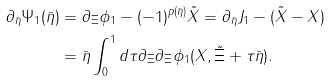<formula> <loc_0><loc_0><loc_500><loc_500>\partial _ { \bar { \eta } } \Psi _ { 1 } ( \bar { \eta } ) & = \partial _ { \Xi } \phi _ { 1 } - ( - 1 ) ^ { p ( \bar { \eta } ) } \tilde { X } = \partial _ { \bar { \eta } } J _ { 1 } - ( \tilde { X } - X ) \\ & = \bar { \eta } \int _ { 0 } ^ { 1 } d \tau \partial _ { \Xi } \partial _ { \Xi } \phi _ { 1 } ( X , \tilde { \Xi } + \tau \bar { \eta } ) .</formula> 